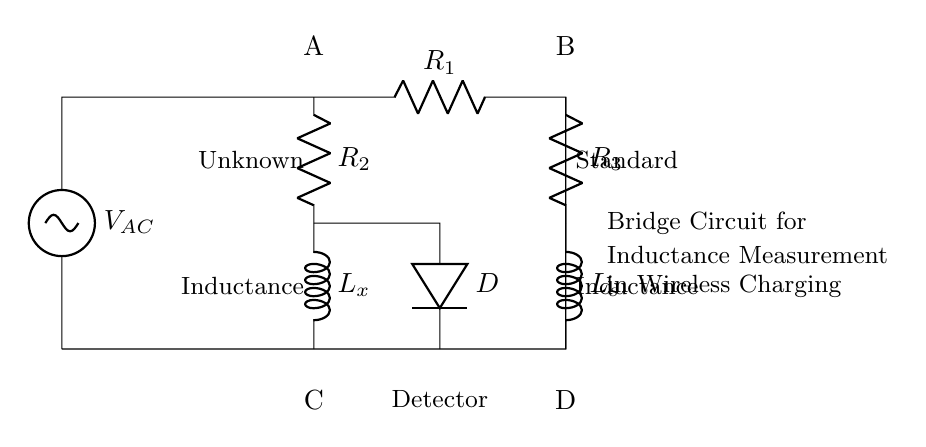What is the type of power source in this circuit? The power source in the circuit is an alternating current source, as indicated by the symbol used for the voltage source, which typically denotes AC voltage.
Answer: AC What are the components used in the bridge circuit? The components used in the bridge circuit are resistors R1, R2, R3, inductors Lx, Ls, and a diode D.
Answer: R1, R2, R3, Lx, Ls, D What is the primary purpose of this circuit? The primary purpose of this circuit is to measure unknown inductance, which is evident from the labeling of Lx as the unknown inductance in the diagram.
Answer: Measure unknown inductance How many resistors are present in the circuit? There are three resistors (R1, R2, R3) present in the circuit, as indicated in the diagram labels.
Answer: Three Why is the diode included in this bridge circuit? The diode is included to ensure that current flows in only one direction during the measurement process, protecting the circuit from reverse polarity or unintended current.
Answer: To allow unidirectional current flow What does Lx represent in the circuit? Lx represents the unknown inductance that needs to be measured, which is specifically designated in the circuit diagram for this purpose.
Answer: Unknown inductance What does the node labeled "Detector" indicate? The node labeled "Detector" indicates a measurement point where the balance of the bridge can be assessed to determine the unknown inductance based on the bridge's operation.
Answer: Measurement point for balance 